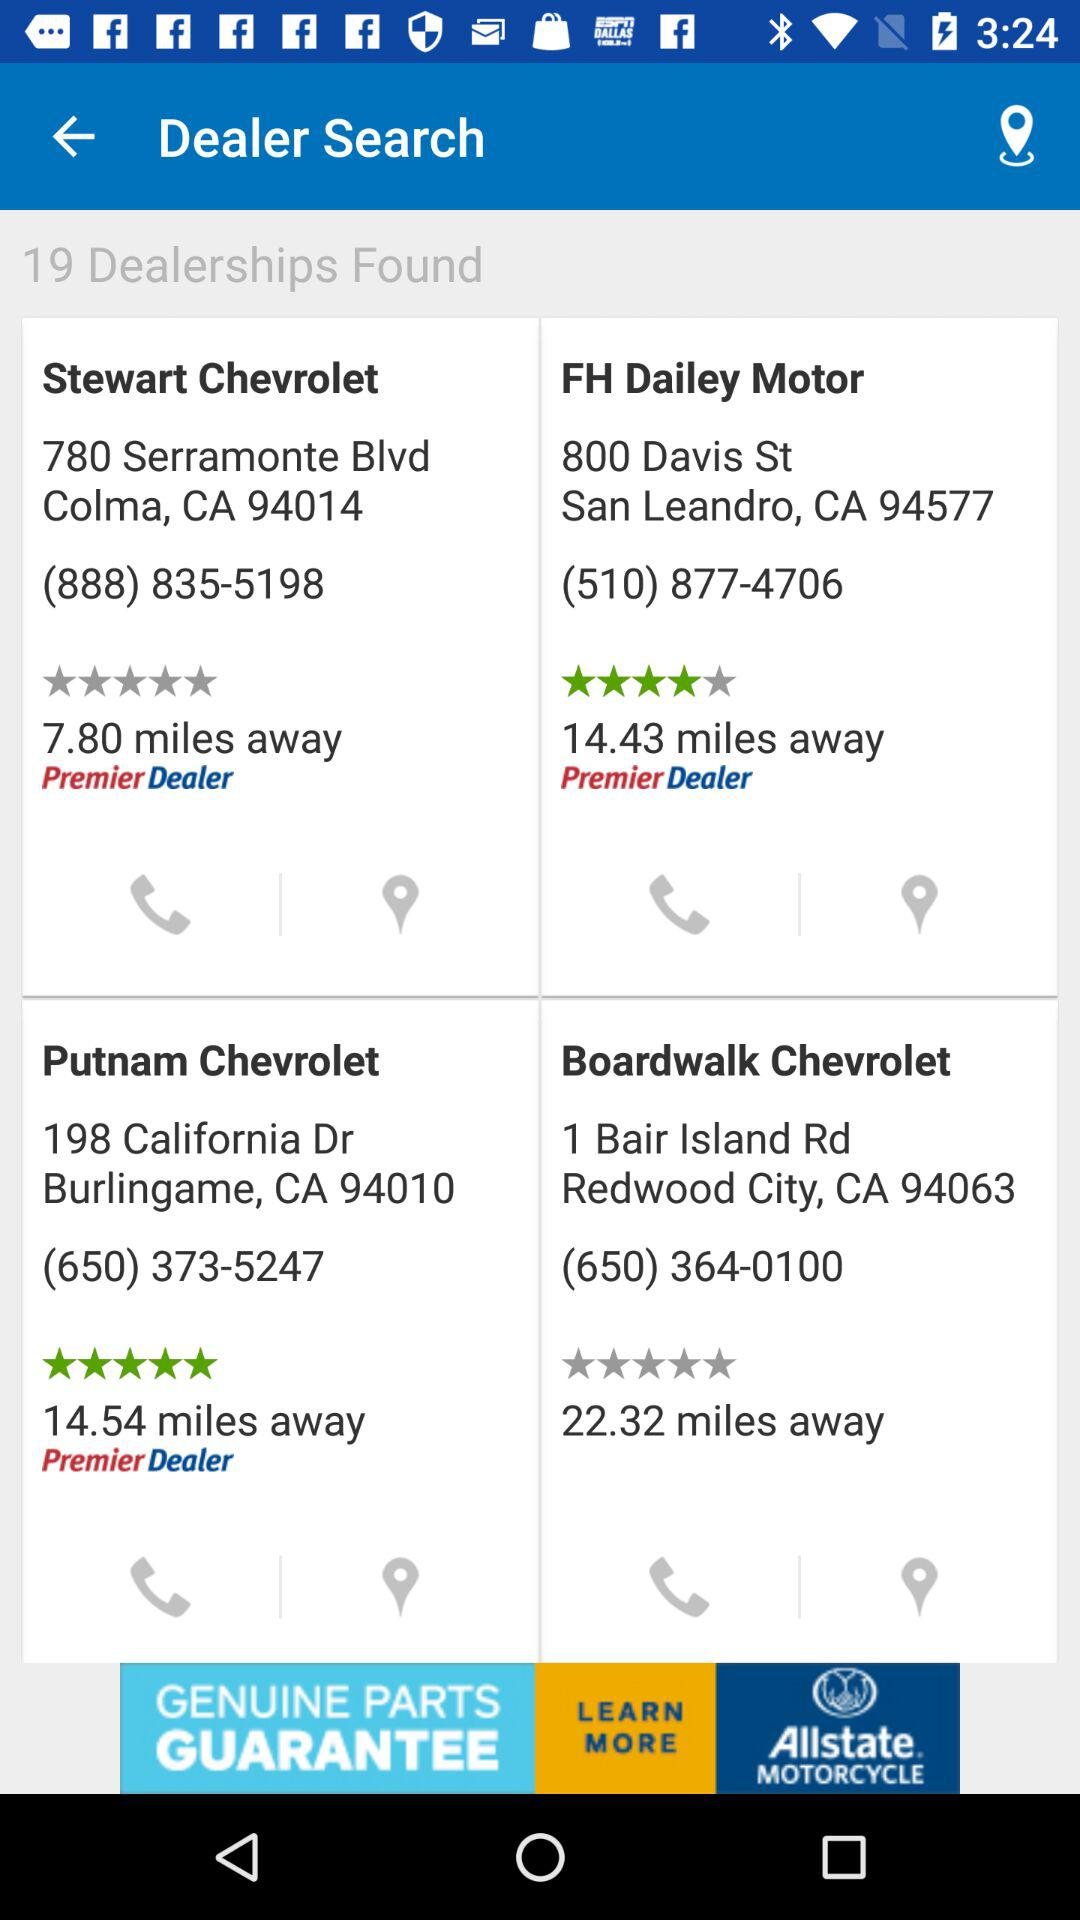Which dealership is closest to me?
Answer the question using a single word or phrase. Stewart Chevrolet 